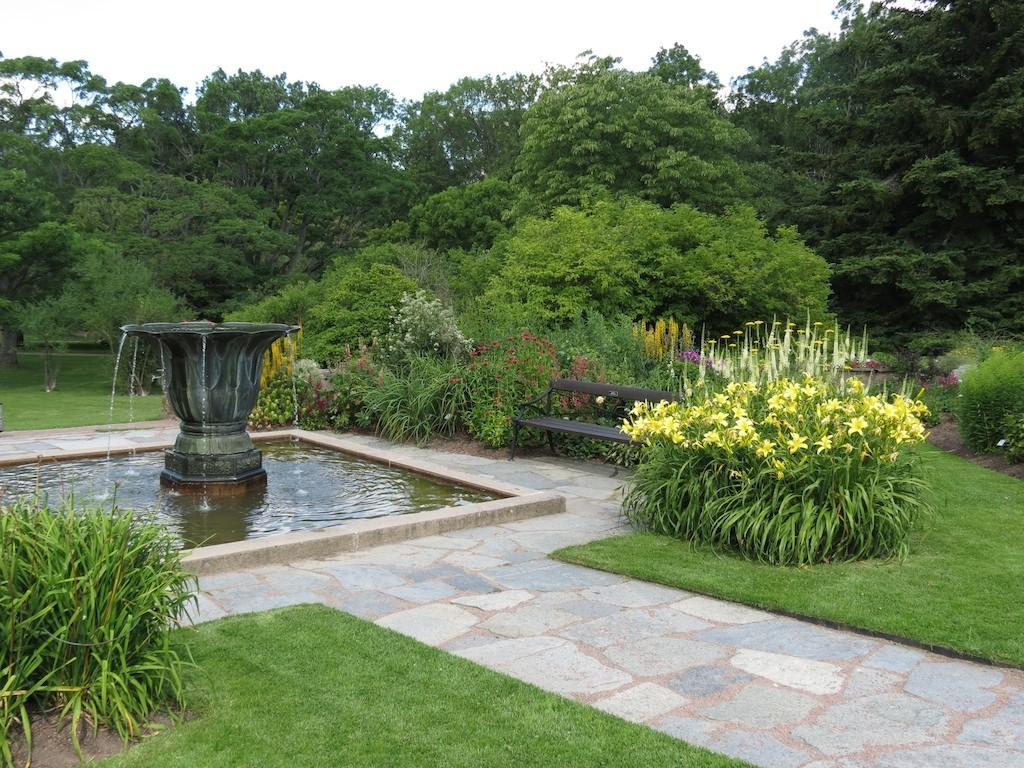What structure is located on the left side of the image? There is a water fountain on the left side of the image. What type of vegetation can be seen in the image? There are plants and trees in the image. What is visible at the top of the image? The sky is visible in the image. Where is the face of the person sitting on the sofa in the image? There is no person sitting on a sofa in the image; it features a water fountain, plants, trees, and the sky. What type of work is being done in the image? There is no work being done in the image; it is a scene of a water fountain, plants, trees, and the sky. 